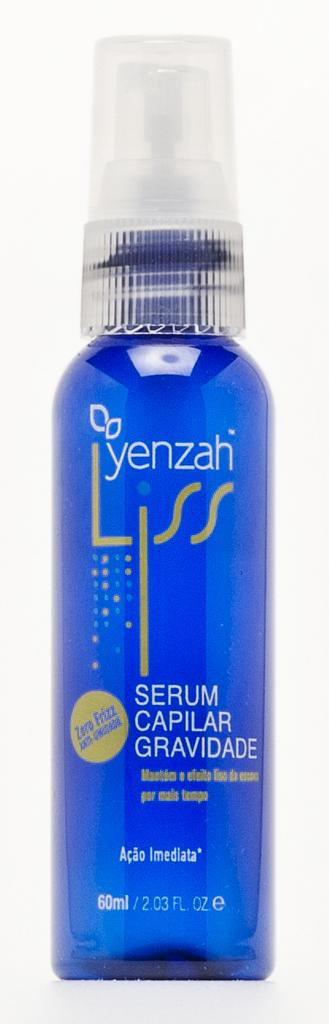Provide a one-sentence caption for the provided image. A bottle containing a blue product and made by Yenzah. 